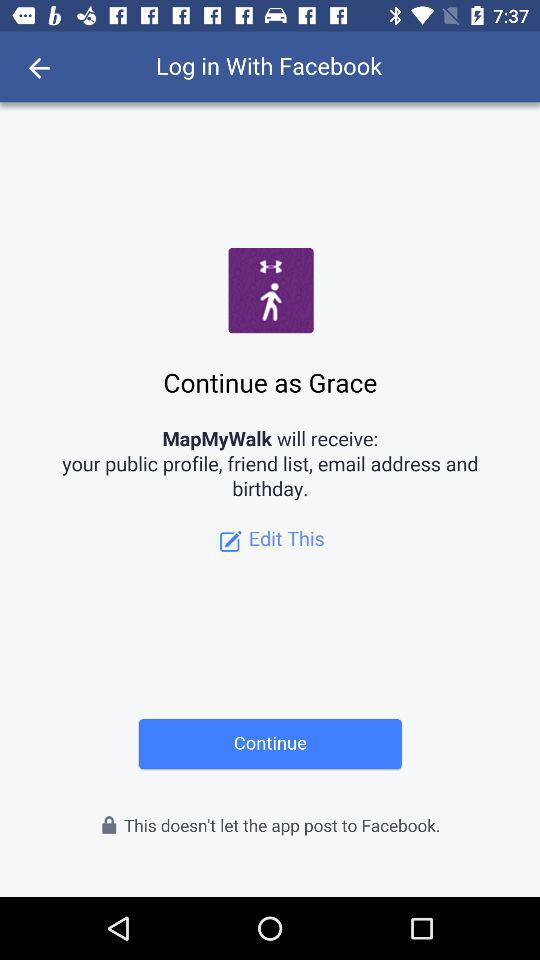What application is asking for permission? The application "MapMyWalk" is asking for permission. 